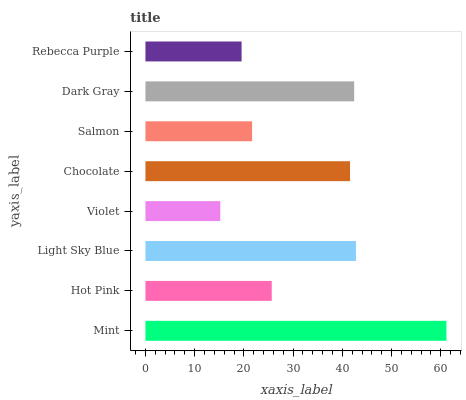Is Violet the minimum?
Answer yes or no. Yes. Is Mint the maximum?
Answer yes or no. Yes. Is Hot Pink the minimum?
Answer yes or no. No. Is Hot Pink the maximum?
Answer yes or no. No. Is Mint greater than Hot Pink?
Answer yes or no. Yes. Is Hot Pink less than Mint?
Answer yes or no. Yes. Is Hot Pink greater than Mint?
Answer yes or no. No. Is Mint less than Hot Pink?
Answer yes or no. No. Is Chocolate the high median?
Answer yes or no. Yes. Is Hot Pink the low median?
Answer yes or no. Yes. Is Violet the high median?
Answer yes or no. No. Is Chocolate the low median?
Answer yes or no. No. 